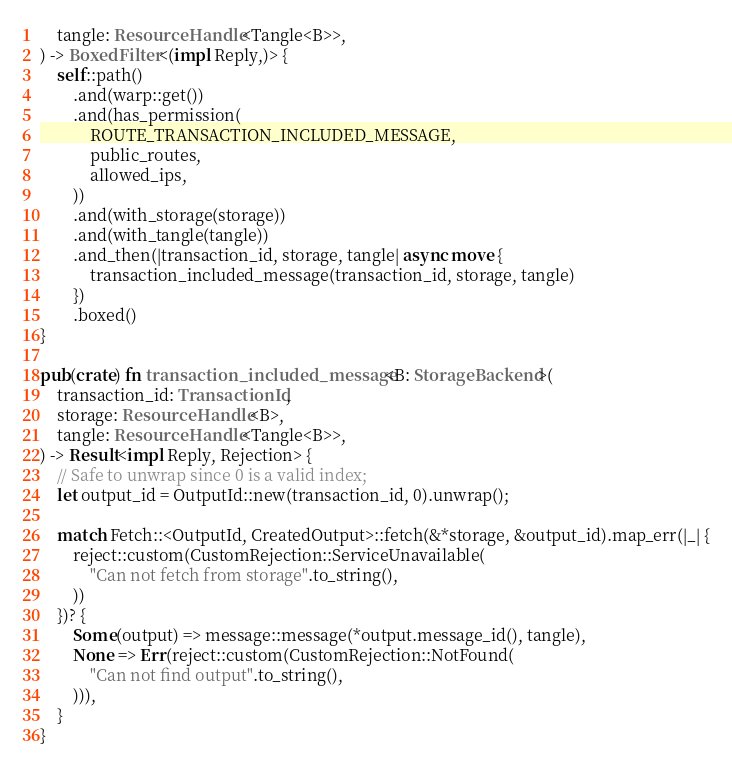<code> <loc_0><loc_0><loc_500><loc_500><_Rust_>    tangle: ResourceHandle<Tangle<B>>,
) -> BoxedFilter<(impl Reply,)> {
    self::path()
        .and(warp::get())
        .and(has_permission(
            ROUTE_TRANSACTION_INCLUDED_MESSAGE,
            public_routes,
            allowed_ips,
        ))
        .and(with_storage(storage))
        .and(with_tangle(tangle))
        .and_then(|transaction_id, storage, tangle| async move {
            transaction_included_message(transaction_id, storage, tangle)
        })
        .boxed()
}

pub(crate) fn transaction_included_message<B: StorageBackend>(
    transaction_id: TransactionId,
    storage: ResourceHandle<B>,
    tangle: ResourceHandle<Tangle<B>>,
) -> Result<impl Reply, Rejection> {
    // Safe to unwrap since 0 is a valid index;
    let output_id = OutputId::new(transaction_id, 0).unwrap();

    match Fetch::<OutputId, CreatedOutput>::fetch(&*storage, &output_id).map_err(|_| {
        reject::custom(CustomRejection::ServiceUnavailable(
            "Can not fetch from storage".to_string(),
        ))
    })? {
        Some(output) => message::message(*output.message_id(), tangle),
        None => Err(reject::custom(CustomRejection::NotFound(
            "Can not find output".to_string(),
        ))),
    }
}
</code> 